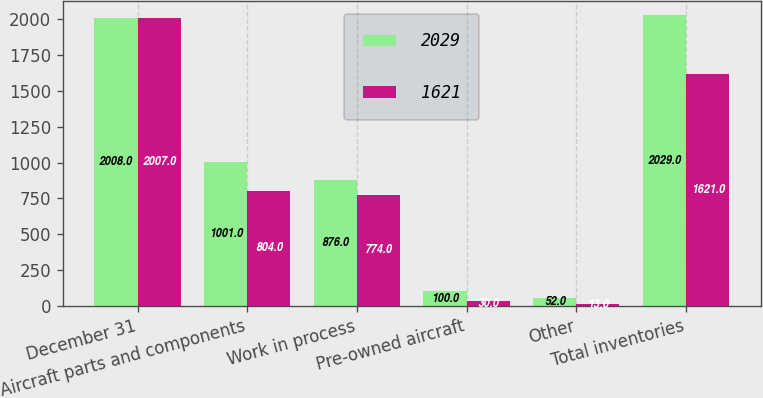Convert chart to OTSL. <chart><loc_0><loc_0><loc_500><loc_500><stacked_bar_chart><ecel><fcel>December 31<fcel>Aircraft parts and components<fcel>Work in process<fcel>Pre-owned aircraft<fcel>Other<fcel>Total inventories<nl><fcel>2029<fcel>2008<fcel>1001<fcel>876<fcel>100<fcel>52<fcel>2029<nl><fcel>1621<fcel>2007<fcel>804<fcel>774<fcel>30<fcel>13<fcel>1621<nl></chart> 